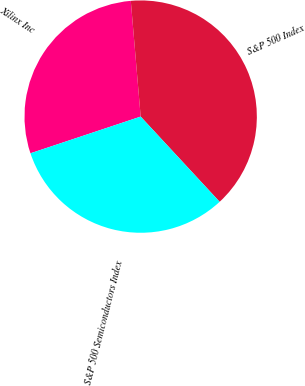Convert chart. <chart><loc_0><loc_0><loc_500><loc_500><pie_chart><fcel>Xilinx Inc<fcel>S&P 500 Index<fcel>S&P 500 Semiconductors Index<nl><fcel>28.76%<fcel>39.46%<fcel>31.78%<nl></chart> 